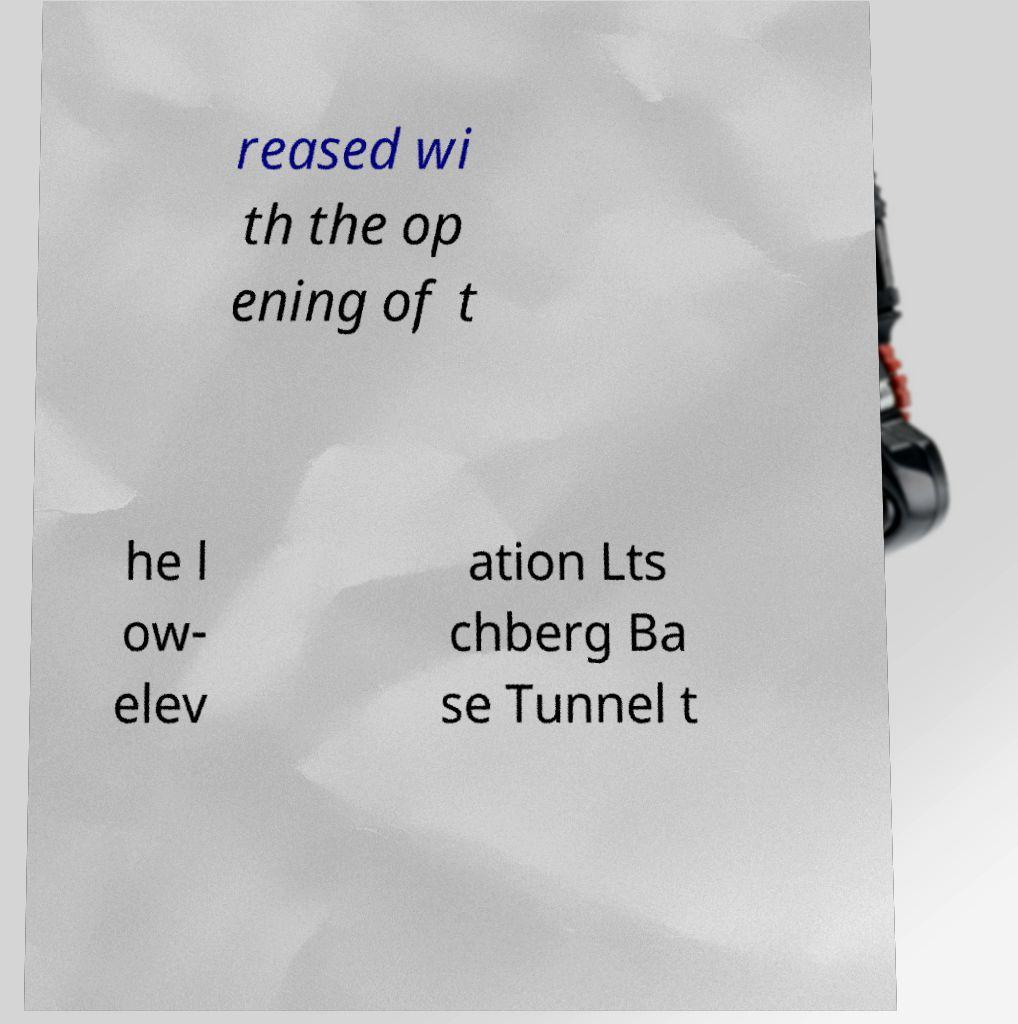Can you accurately transcribe the text from the provided image for me? reased wi th the op ening of t he l ow- elev ation Lts chberg Ba se Tunnel t 